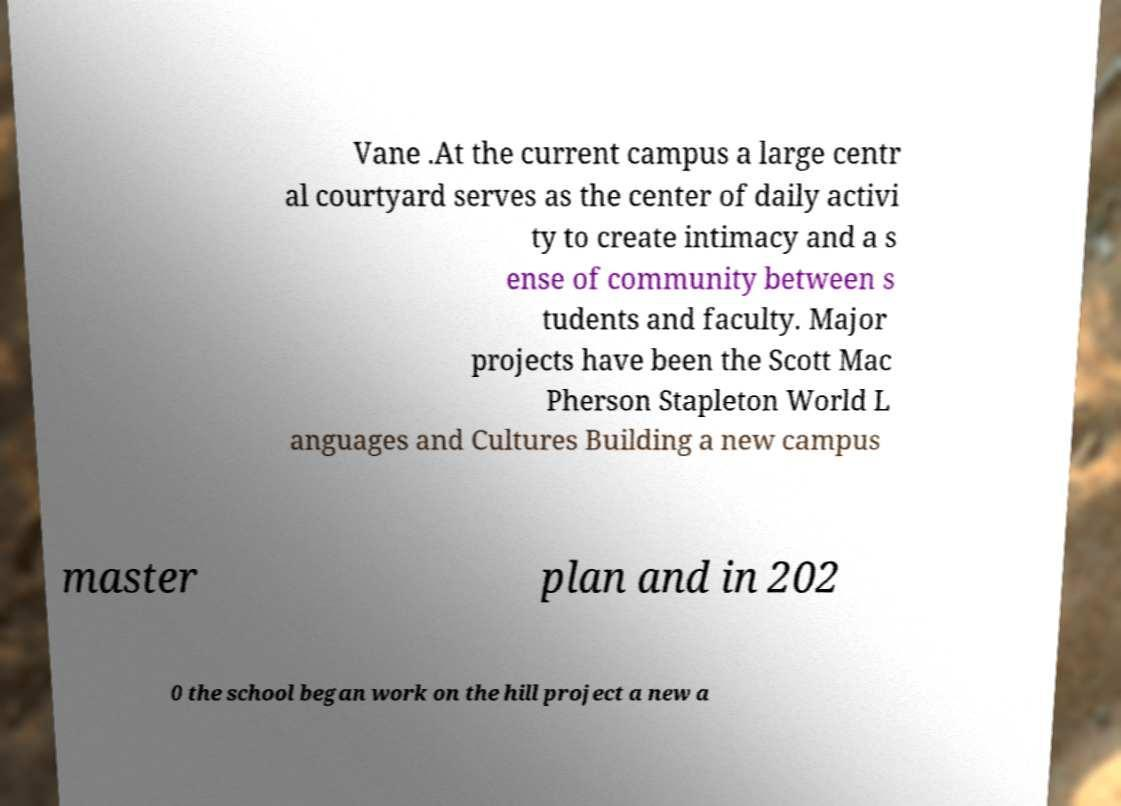There's text embedded in this image that I need extracted. Can you transcribe it verbatim? Vane .At the current campus a large centr al courtyard serves as the center of daily activi ty to create intimacy and a s ense of community between s tudents and faculty. Major projects have been the Scott Mac Pherson Stapleton World L anguages and Cultures Building a new campus master plan and in 202 0 the school began work on the hill project a new a 